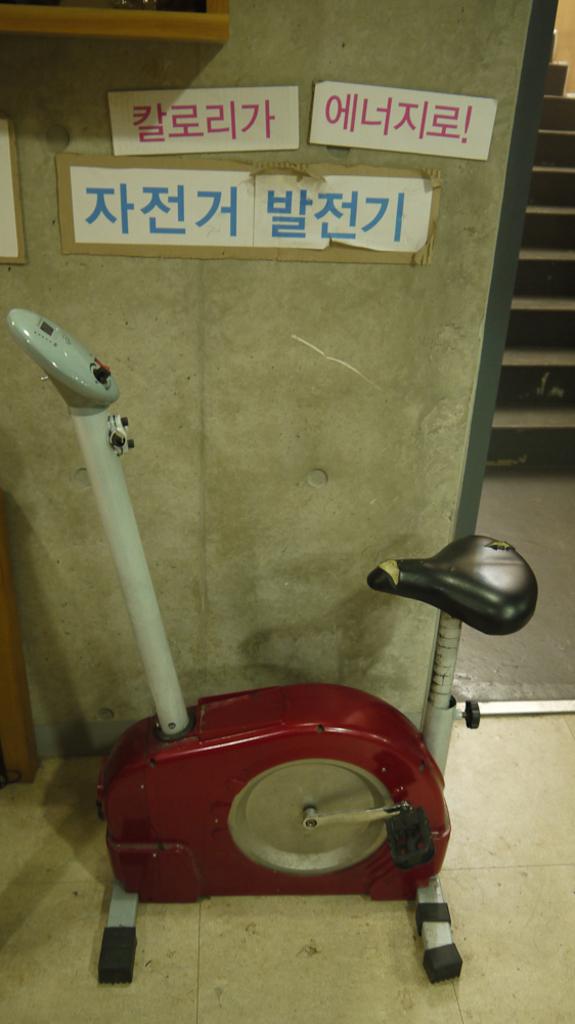All in foreign language?
Your answer should be very brief. Yes. 